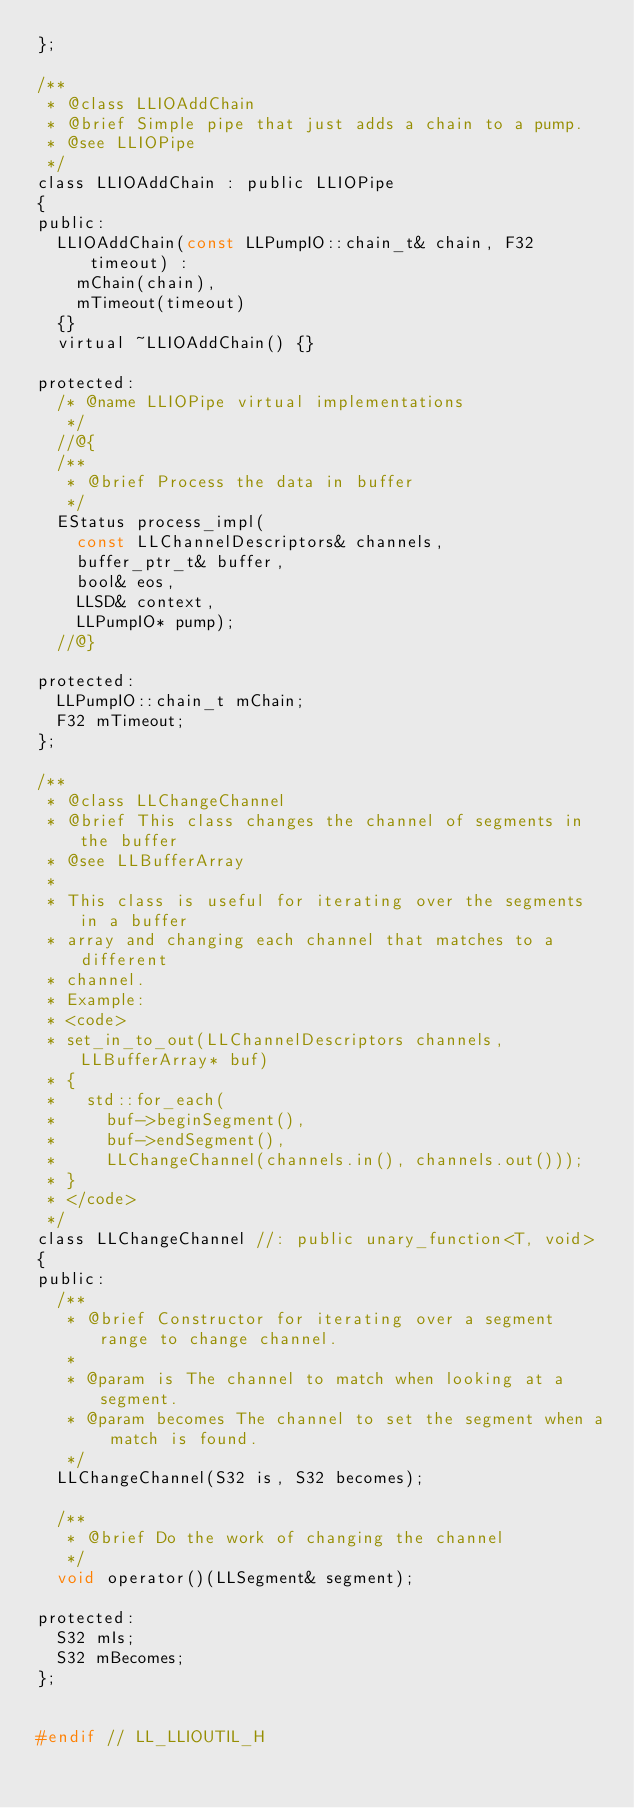<code> <loc_0><loc_0><loc_500><loc_500><_C_>};

/** 
 * @class LLIOAddChain
 * @brief Simple pipe that just adds a chain to a pump.
 * @see LLIOPipe
 */
class LLIOAddChain : public LLIOPipe
{
public:
	LLIOAddChain(const LLPumpIO::chain_t& chain, F32 timeout) :
		mChain(chain),
		mTimeout(timeout)
	{}
	virtual ~LLIOAddChain() {}

protected:
	/* @name LLIOPipe virtual implementations
	 */
	//@{
	/** 
	 * @brief Process the data in buffer
	 */
	EStatus process_impl(
		const LLChannelDescriptors& channels,
		buffer_ptr_t& buffer,
		bool& eos,
		LLSD& context,
		LLPumpIO* pump);
	//@}

protected:
	LLPumpIO::chain_t mChain;
	F32 mTimeout;
};

/** 
 * @class LLChangeChannel
 * @brief This class changes the channel of segments in the buffer
 * @see LLBufferArray
 *
 * This class is useful for iterating over the segments in a buffer
 * array and changing each channel that matches to a different
 * channel.
 * Example:
 * <code>
 * set_in_to_out(LLChannelDescriptors channels, LLBufferArray* buf)
 * {
 *   std::for_each(
 *     buf->beginSegment(),
 *     buf->endSegment(),
 *     LLChangeChannel(channels.in(), channels.out()));
 * }
 * </code>
 */
class LLChangeChannel //: public unary_function<T, void>
{
public:
	/** 
	 * @brief Constructor for iterating over a segment range to change channel.
	 *
	 * @param is The channel to match when looking at a segment.
	 * @param becomes The channel to set the segment when a match is found.
	 */
	LLChangeChannel(S32 is, S32 becomes);

	/** 
	 * @brief Do the work of changing the channel
	 */
	void operator()(LLSegment& segment);

protected:
	S32 mIs;
	S32 mBecomes;
};


#endif // LL_LLIOUTIL_H
</code> 